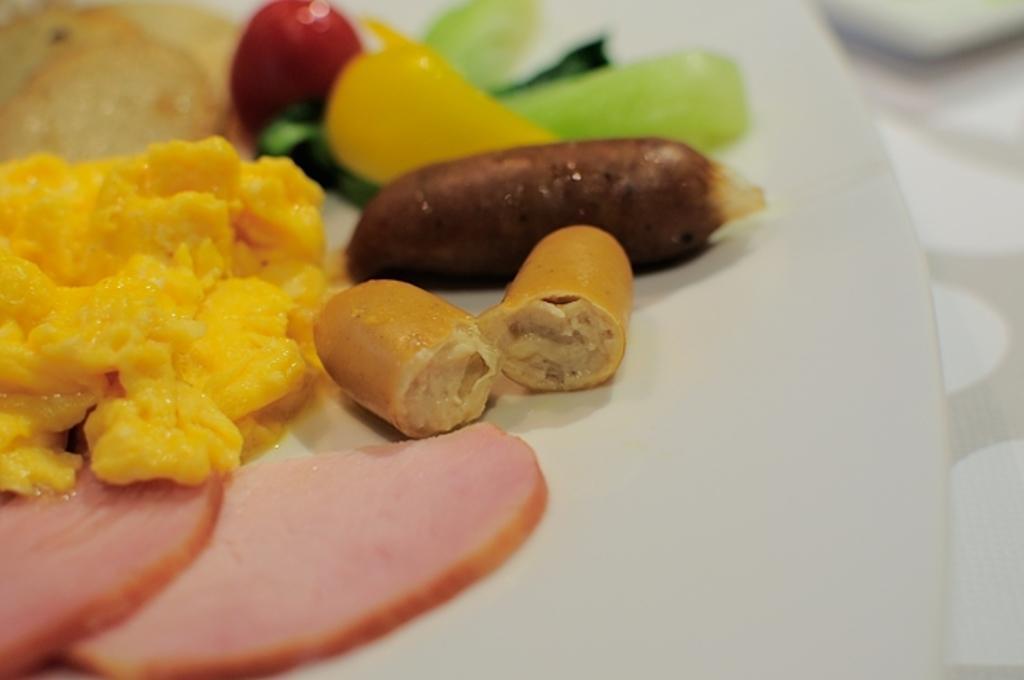In one or two sentences, can you explain what this image depicts? Here we can see food items in a plate on a platform. 